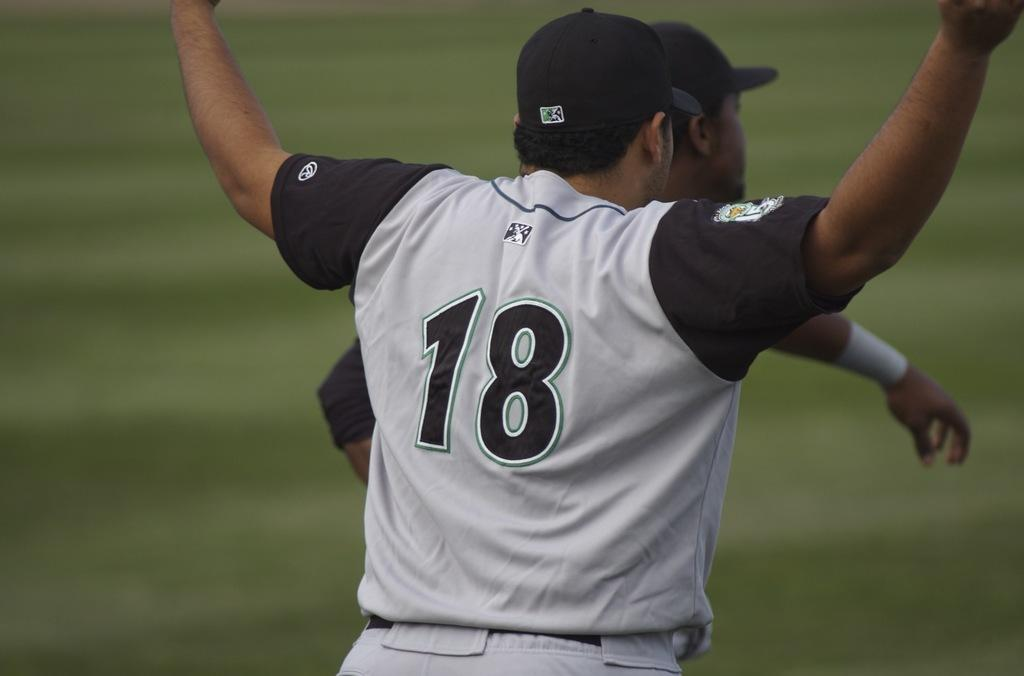<image>
Provide a brief description of the given image. The baseball player holding up his arms has the number 18 on his jersey. 